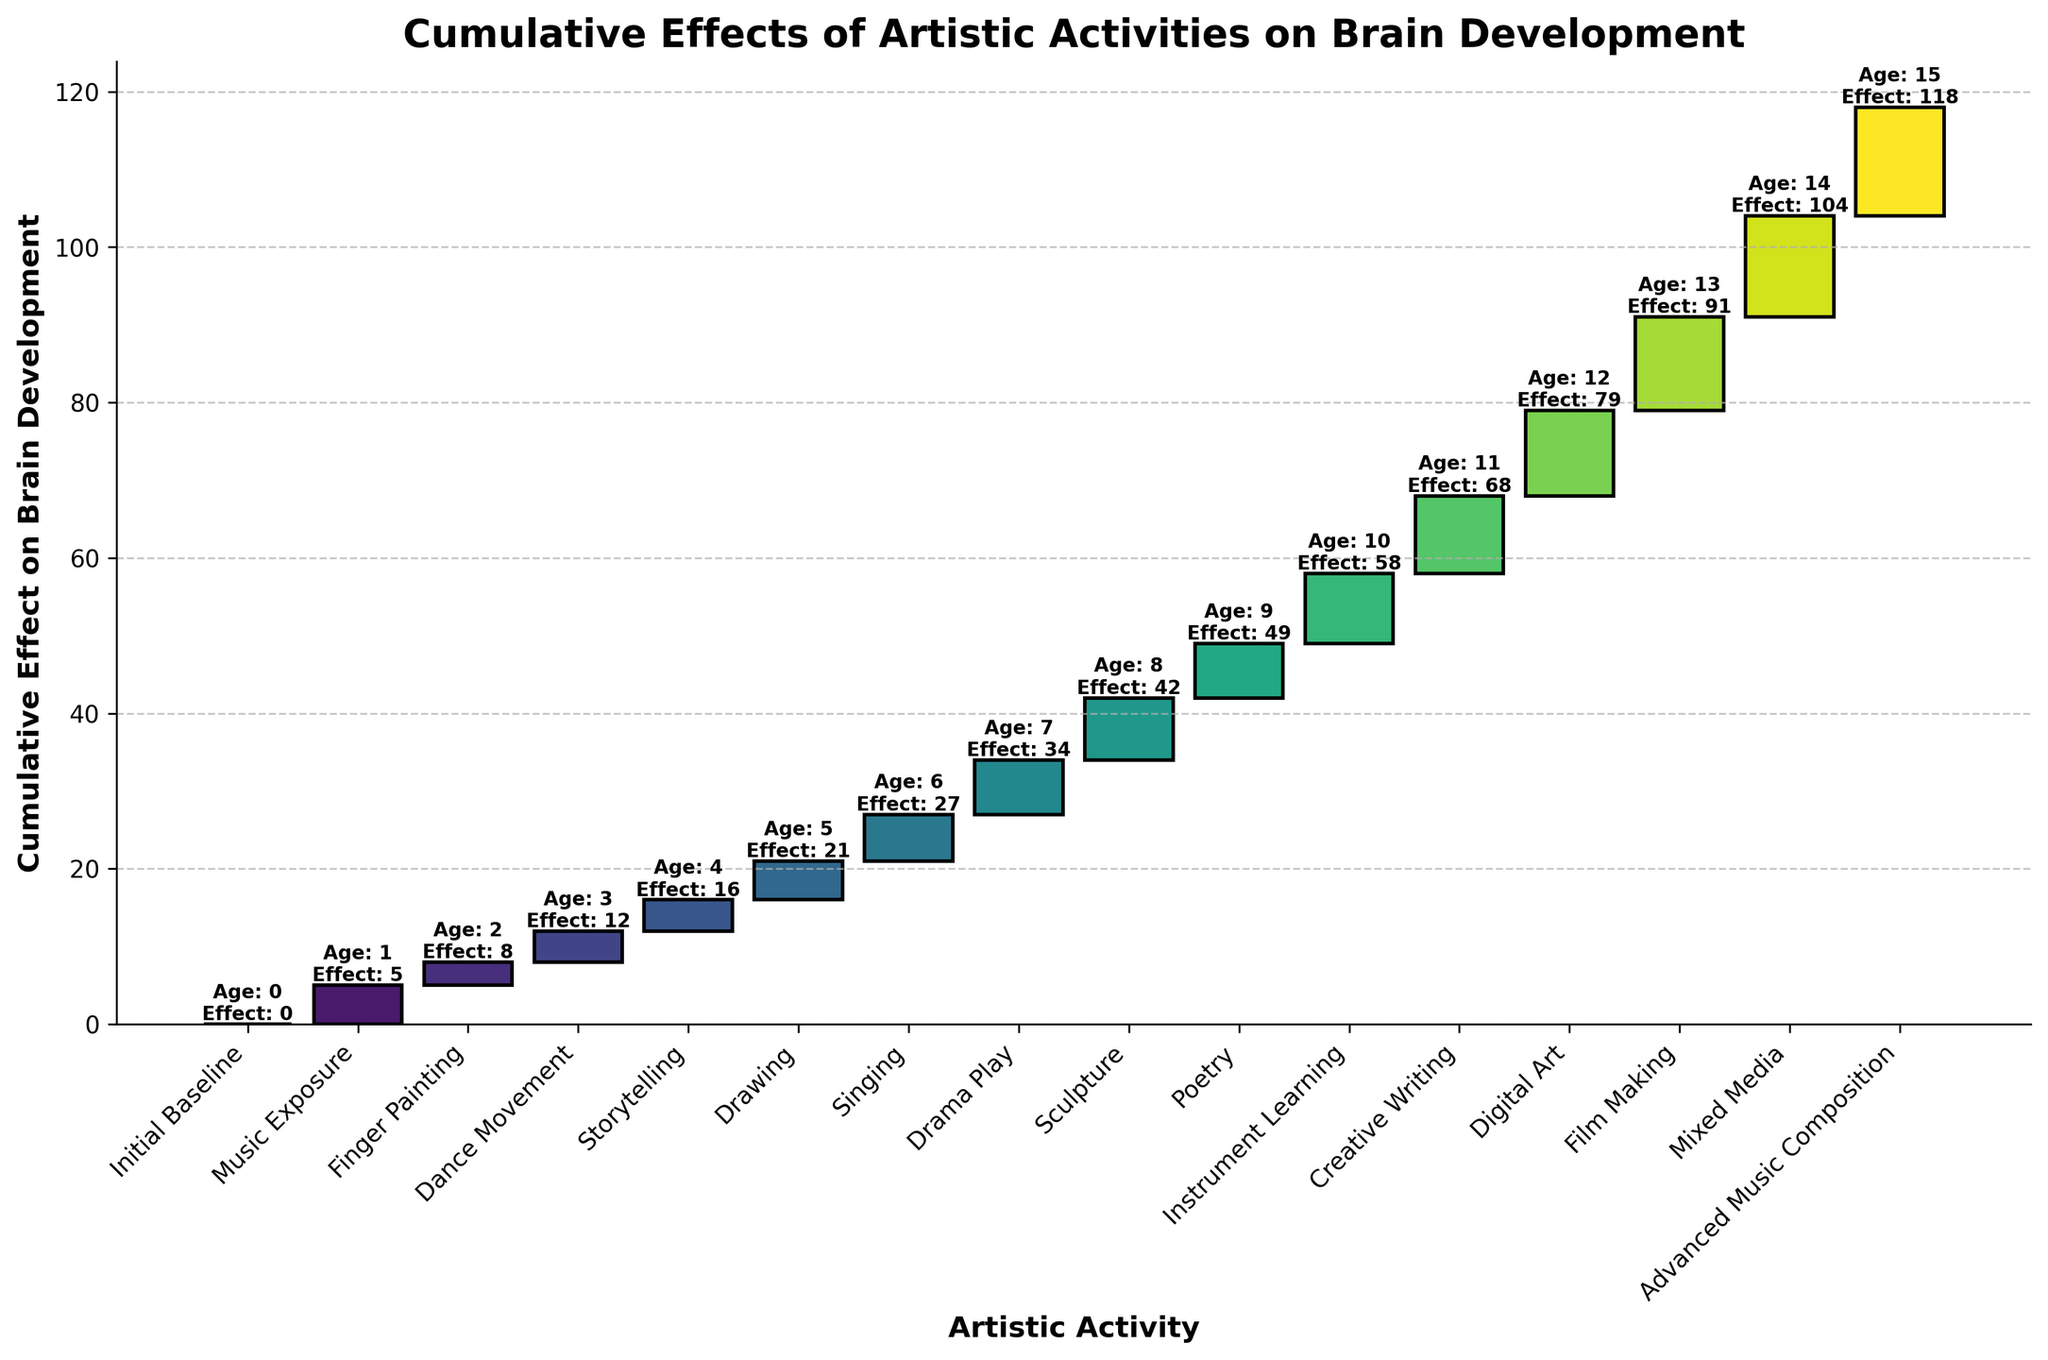What is the title of the waterfall chart? The title is usually located at the top of the chart and provides a summary of what the chart is about.
Answer: Cumulative Effects of Artistic Activities on Brain Development How many artistic activities are listed in the chart? Count the number of unique artistic activities mentioned along the x-axis.
Answer: 16 Which artistic activity contributes the most to brain development? Identify the activity with the highest cumulative effect value on the y-axis at the end of the period.
Answer: Advanced Music Composition What is the cumulative effect on brain development by the age of 5? Look for the cumulative effect value corresponding to the age 5 and the activity Drawing.
Answer: 21 At which age does the cumulative effect exceed 50? Identify the age and corresponding activity where the cumulative effect surpasses 50 on the y-axis.
Answer: 10 (Instrument Learning) What is the difference in cumulative effect between ages 4 and 8? Subtract the cumulative effect at age 4 from the cumulative effect at age 8. Ages 4 and 8 correspond to Storytelling and Sculpture, respectively. 49 - 16 = 33
Answer: 33 How does the cumulative effect change from age 12 to 15? Calculate the difference between cumulative effects at ages 12 and 15. Subtract the value at age 12 (79, Digital Art) from the value at age 15 (118, Advanced Music Composition). 118 - 79 = 39
Answer: 39 If we remove the contribution of Digital Art, what would be the cumulative effect at age 14? Subtract the contribution of Digital Art at age 12 (79) from the contribution at age 14 (104), considering the effect up to age 11 (Creative Writing) which is 68. 68 (up to age 11) + 25 (Mixed Media from age 12-14 because 104-79=25)
Answer: 93 What artistic activity marks the midpoint (50% mark) of the cumulative effect by adolescence? Identify which activity’s cumulative effect is closest to half of the maximum cumulative effect value (near 59, which is half of 118).
Answer: Instrument Learning How much does Sculpture contribute to the cumulative brain development effect compared to Storytelling? Calculate the difference between cumulative effects due to Sculpture (42) and Storytelling (16). 42 - 16 = 26
Answer: 26 